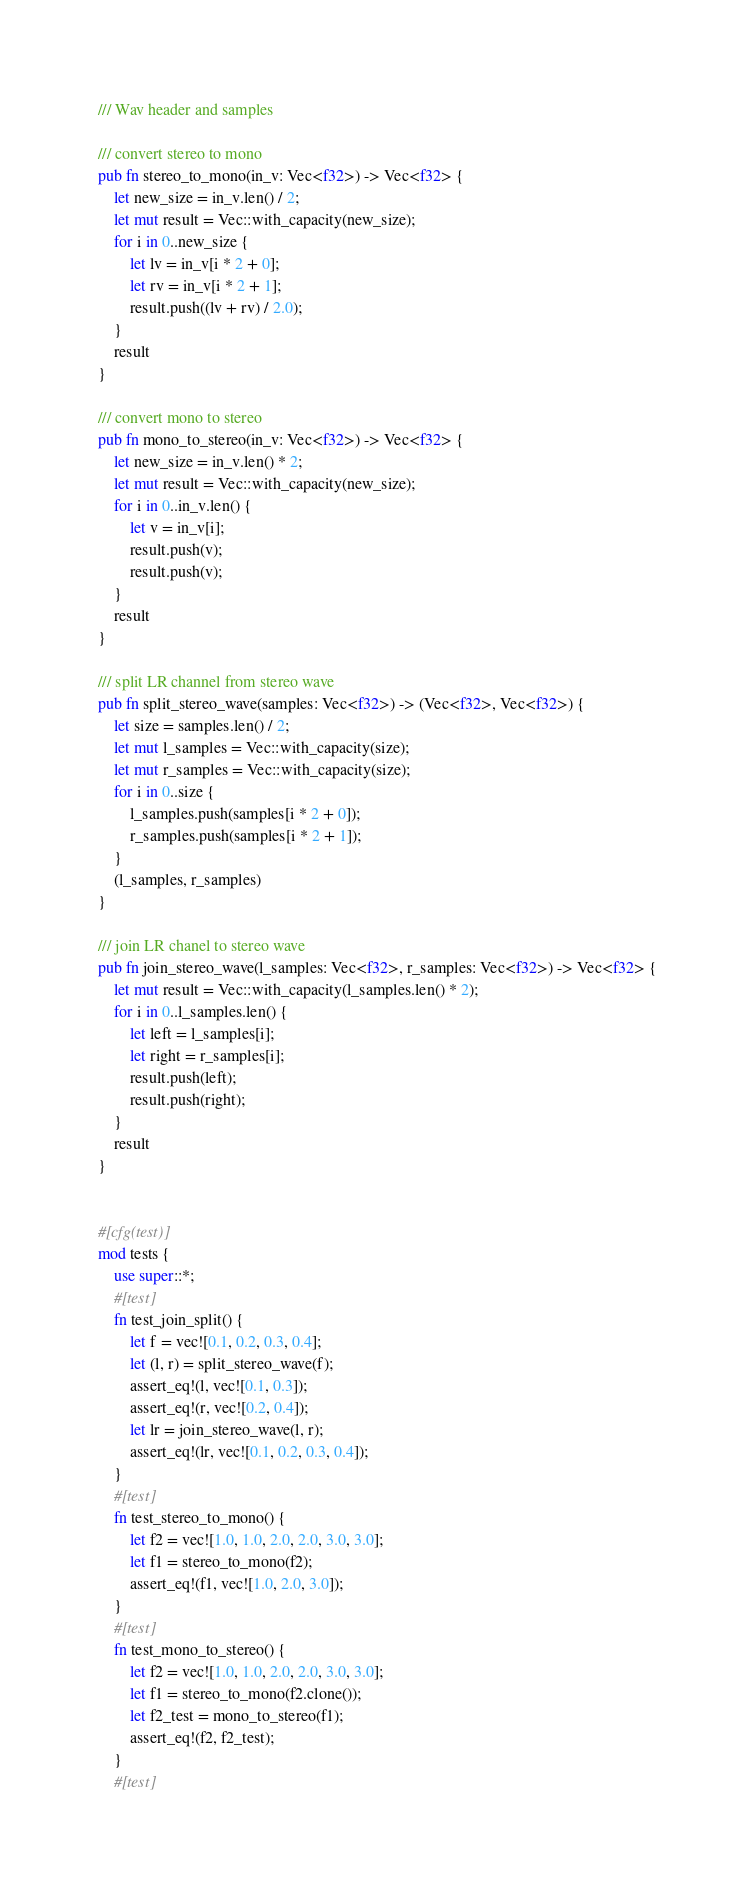Convert code to text. <code><loc_0><loc_0><loc_500><loc_500><_Rust_>/// Wav header and samples

/// convert stereo to mono
pub fn stereo_to_mono(in_v: Vec<f32>) -> Vec<f32> {
    let new_size = in_v.len() / 2;
    let mut result = Vec::with_capacity(new_size);
    for i in 0..new_size {
        let lv = in_v[i * 2 + 0];
        let rv = in_v[i * 2 + 1];
        result.push((lv + rv) / 2.0);
    }
    result
}

/// convert mono to stereo
pub fn mono_to_stereo(in_v: Vec<f32>) -> Vec<f32> {
    let new_size = in_v.len() * 2;
    let mut result = Vec::with_capacity(new_size);
    for i in 0..in_v.len() {
        let v = in_v[i];
        result.push(v);
        result.push(v);
    }
    result
}

/// split LR channel from stereo wave
pub fn split_stereo_wave(samples: Vec<f32>) -> (Vec<f32>, Vec<f32>) {
    let size = samples.len() / 2;
    let mut l_samples = Vec::with_capacity(size);
    let mut r_samples = Vec::with_capacity(size);
    for i in 0..size {
        l_samples.push(samples[i * 2 + 0]);
        r_samples.push(samples[i * 2 + 1]);
    }
    (l_samples, r_samples)
}

/// join LR chanel to stereo wave
pub fn join_stereo_wave(l_samples: Vec<f32>, r_samples: Vec<f32>) -> Vec<f32> {
    let mut result = Vec::with_capacity(l_samples.len() * 2);
    for i in 0..l_samples.len() {
        let left = l_samples[i];
        let right = r_samples[i];
        result.push(left);
        result.push(right);
    }
    result
}


#[cfg(test)]
mod tests {
    use super::*;
    #[test]
    fn test_join_split() {
        let f = vec![0.1, 0.2, 0.3, 0.4];
        let (l, r) = split_stereo_wave(f);
        assert_eq!(l, vec![0.1, 0.3]);
        assert_eq!(r, vec![0.2, 0.4]);
        let lr = join_stereo_wave(l, r);
        assert_eq!(lr, vec![0.1, 0.2, 0.3, 0.4]);
    }
    #[test]
    fn test_stereo_to_mono() {
        let f2 = vec![1.0, 1.0, 2.0, 2.0, 3.0, 3.0];
        let f1 = stereo_to_mono(f2);
        assert_eq!(f1, vec![1.0, 2.0, 3.0]);
    }
    #[test]
    fn test_mono_to_stereo() {
        let f2 = vec![1.0, 1.0, 2.0, 2.0, 3.0, 3.0];
        let f1 = stereo_to_mono(f2.clone());
        let f2_test = mono_to_stereo(f1);
        assert_eq!(f2, f2_test);
    }
    #[test]</code> 